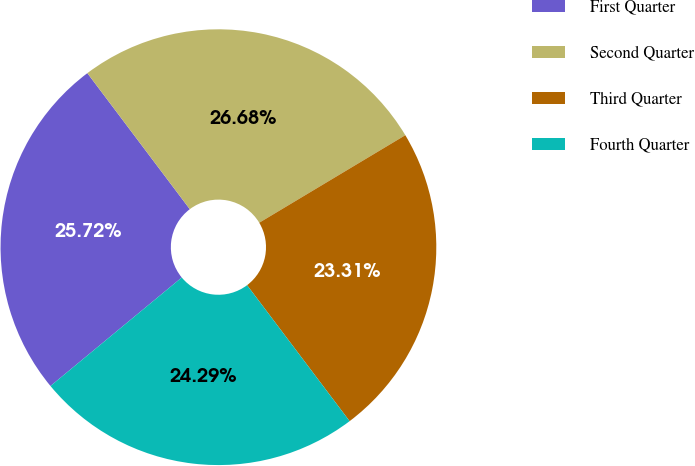Convert chart to OTSL. <chart><loc_0><loc_0><loc_500><loc_500><pie_chart><fcel>First Quarter<fcel>Second Quarter<fcel>Third Quarter<fcel>Fourth Quarter<nl><fcel>25.72%<fcel>26.68%<fcel>23.31%<fcel>24.29%<nl></chart> 